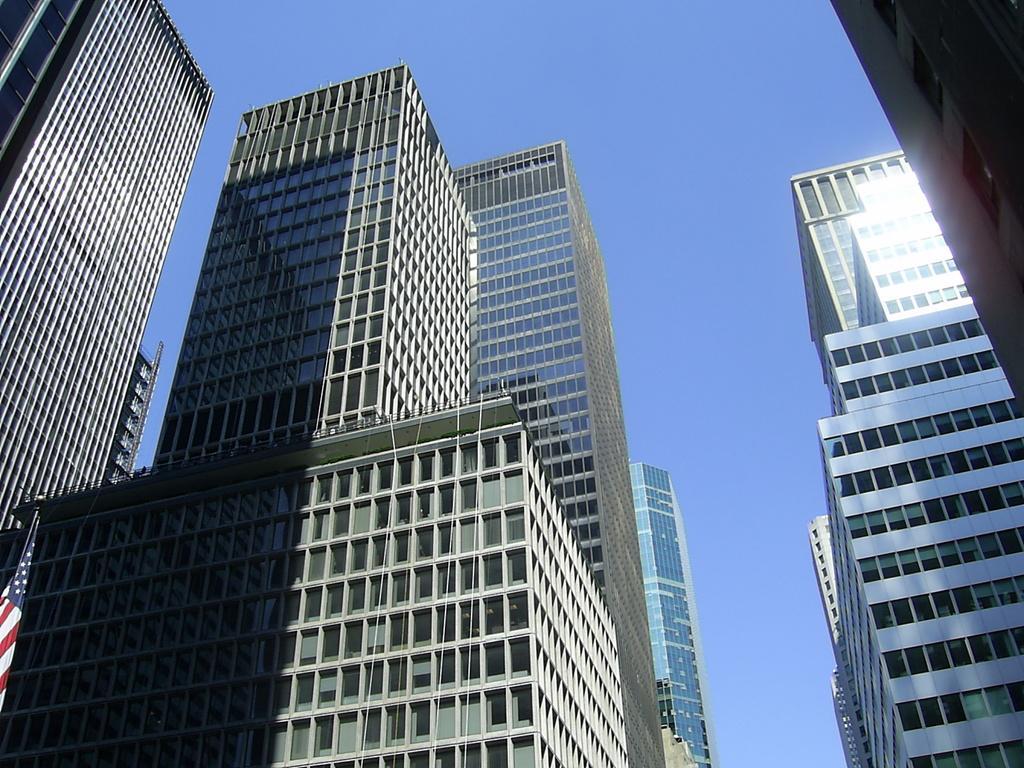Can you describe this image briefly? This picture is taken from the outside of the glass building. In the background, we can see a sky. On the left side, we can also see a flag. 